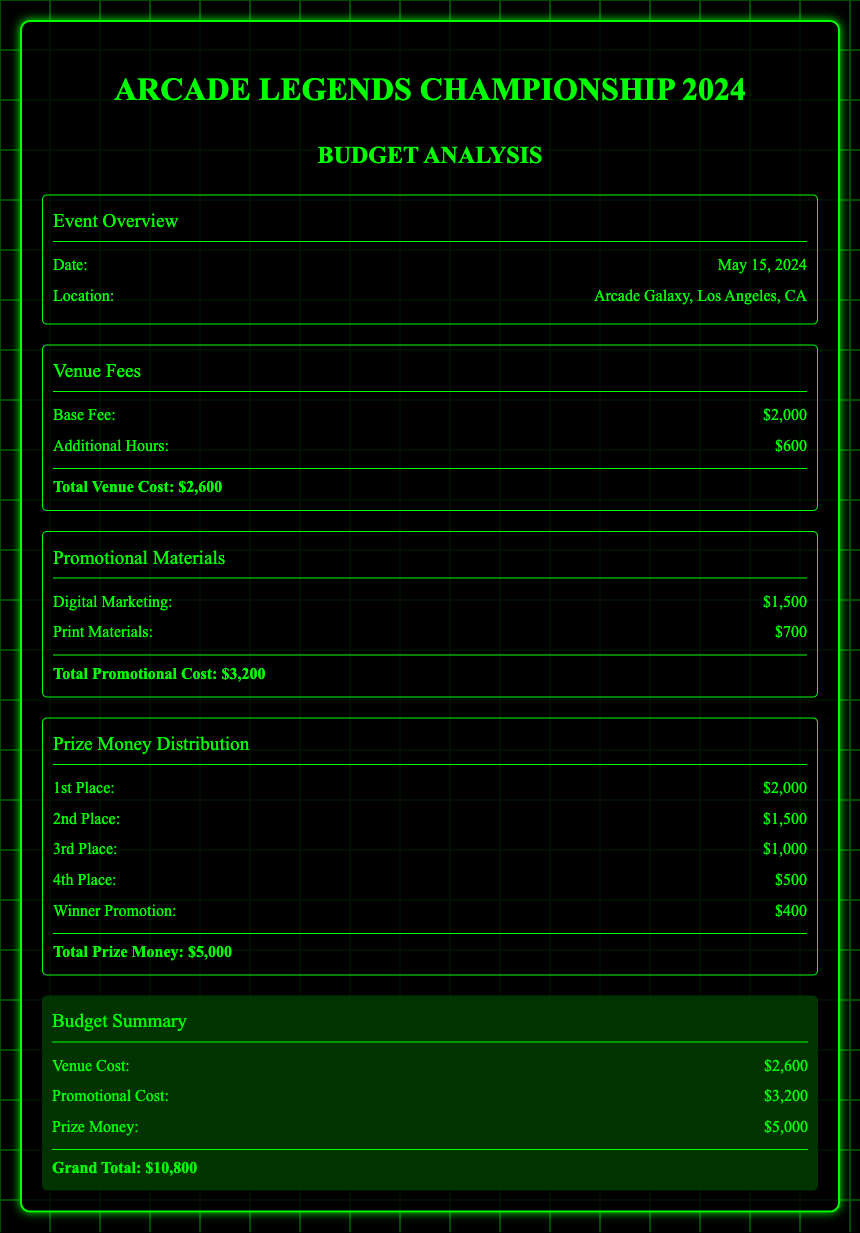what is the date of the event? The date of the event is specified in the overview section of the document.
Answer: May 15, 2024 what is the location of the championship? The location is mentioned in the event overview section, providing details about where the event will take place.
Answer: Arcade Galaxy, Los Angeles, CA what is the total venue cost? The total venue cost is provided at the end of the venue fees section, summing up the base fee and additional charges.
Answer: $2,600 what is the total promotional cost? The total promotional cost is calculated in the promotional materials section, adding the costs associated with digital and print materials.
Answer: $3,200 what is the prize money for the 1st place? The prize money for the 1st place is listed in the prize money distribution section of the document.
Answer: $2,000 how much is given to the 2nd place? The document specifies the prize distribution for different places, including the amount for the second place.
Answer: $1,500 what is the total prize money awarded? The total prize money is the sum of all amounts distributed according to the prize money distribution section.
Answer: $5,000 what is the grand total budget for the event? The grand total is mentioned in the budget summary, representing the sum of all costs involved in the event.
Answer: $10,800 how much is allocated for winner promotion? The amount set aside for winner promotion is included in the prize money distribution.
Answer: $400 